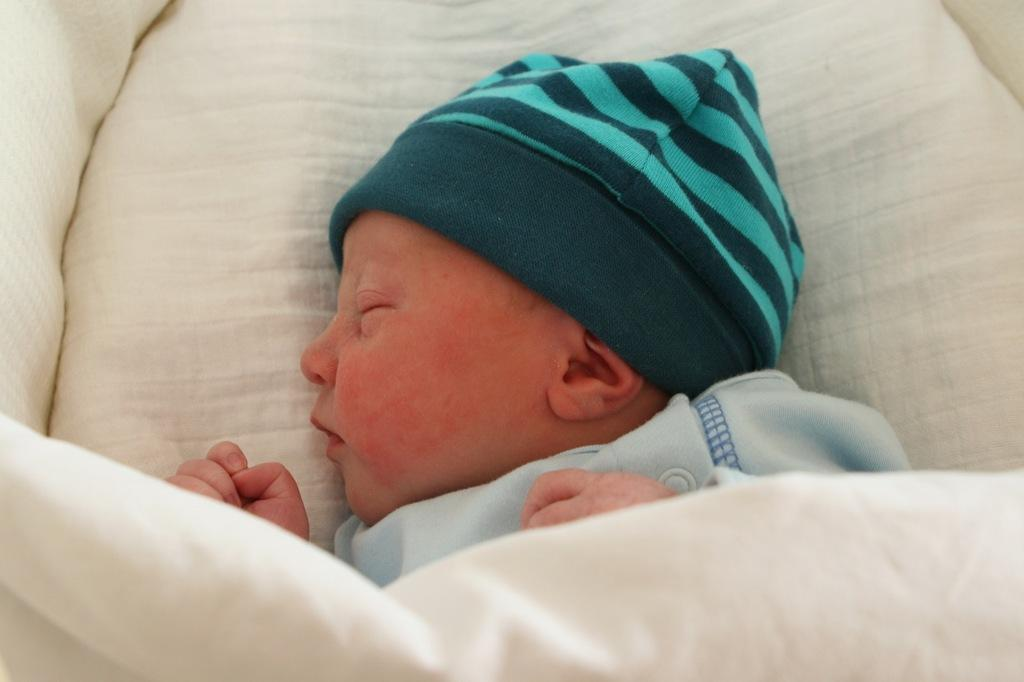What is the main subject of the image? There is a baby in the image. What is the baby doing in the image? The baby is sleeping. What is located at the bottom of the image? There is a blanket at the bottom of the image. What place does the baby want to visit in the image? The image does not provide any information about the baby's desires or intentions, so it cannot be determined from the image. 